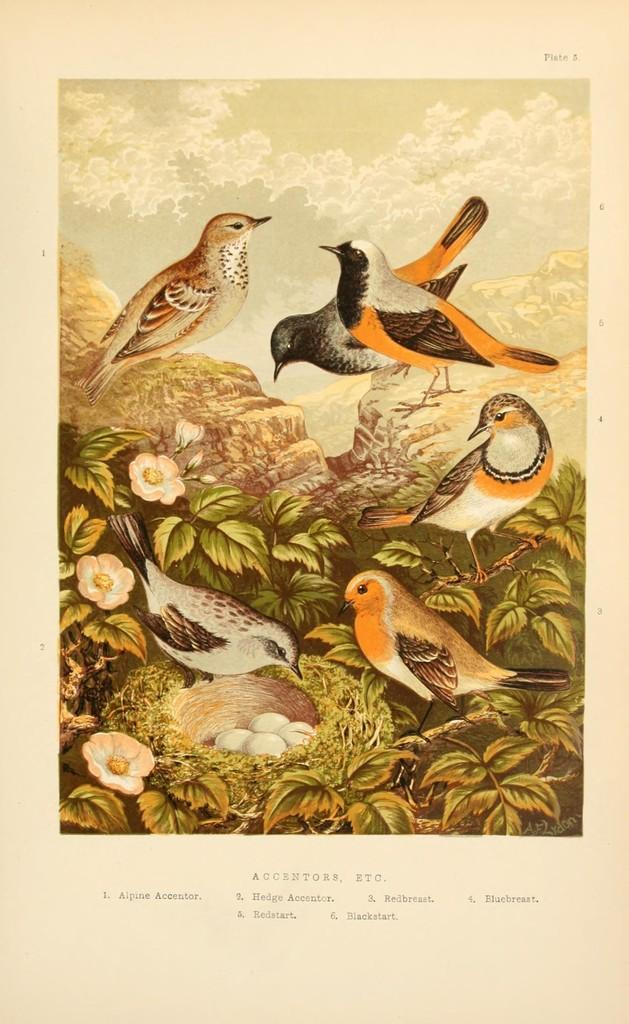What type of animals can be seen in the image? There are birds in the image. What is unique about the appearance of the birds? The birds have multi-colored feathers. What other elements can be seen in the image besides the birds? There are flowers, eggs, and leaves in the image. What color are the flowers and eggs in the image? The flowers and eggs are white. What color are the leaves in the image? The leaves in the image are green. Can you tell me what type of lawyer the bird is representing in the image? There is no lawyer or legal representation present in the image; it features birds, flowers, eggs, and leaves. How does the bird laugh in the image? Birds do not laugh, as they are animals and do not possess the ability to laugh. 